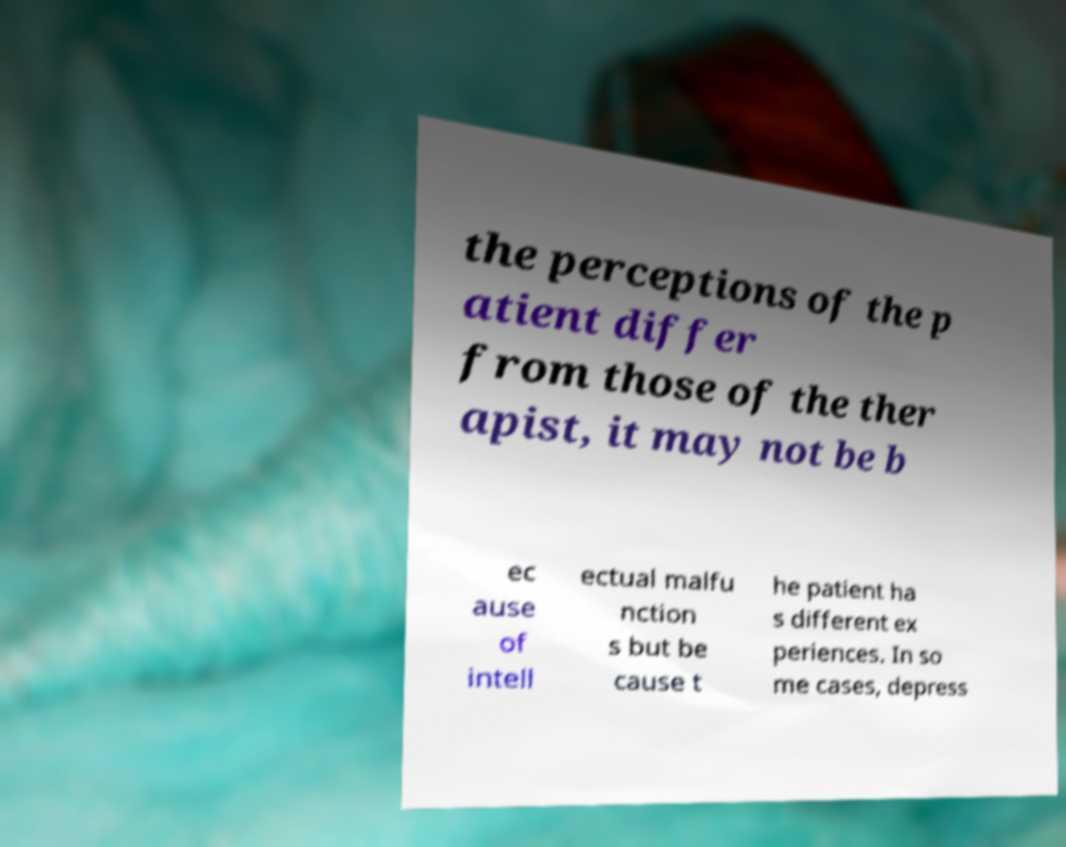Please read and relay the text visible in this image. What does it say? the perceptions of the p atient differ from those of the ther apist, it may not be b ec ause of intell ectual malfu nction s but be cause t he patient ha s different ex periences. In so me cases, depress 